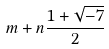<formula> <loc_0><loc_0><loc_500><loc_500>m + n \frac { 1 + \sqrt { - 7 } } { 2 }</formula> 